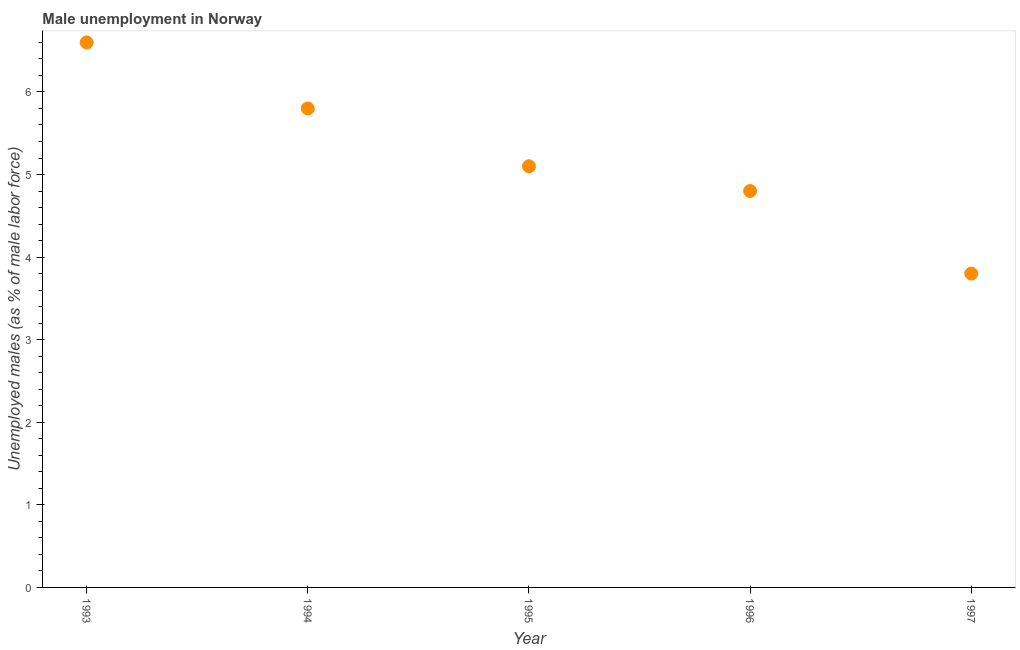What is the unemployed males population in 1993?
Ensure brevity in your answer.  6.6. Across all years, what is the maximum unemployed males population?
Make the answer very short. 6.6. Across all years, what is the minimum unemployed males population?
Give a very brief answer. 3.8. What is the sum of the unemployed males population?
Make the answer very short. 26.1. What is the difference between the unemployed males population in 1993 and 1994?
Offer a very short reply. 0.8. What is the average unemployed males population per year?
Offer a terse response. 5.22. What is the median unemployed males population?
Make the answer very short. 5.1. What is the ratio of the unemployed males population in 1993 to that in 1995?
Ensure brevity in your answer.  1.29. Is the difference between the unemployed males population in 1994 and 1995 greater than the difference between any two years?
Keep it short and to the point. No. What is the difference between the highest and the second highest unemployed males population?
Ensure brevity in your answer.  0.8. What is the difference between the highest and the lowest unemployed males population?
Make the answer very short. 2.8. In how many years, is the unemployed males population greater than the average unemployed males population taken over all years?
Your answer should be very brief. 2. Are the values on the major ticks of Y-axis written in scientific E-notation?
Your response must be concise. No. Does the graph contain any zero values?
Your answer should be compact. No. Does the graph contain grids?
Offer a terse response. No. What is the title of the graph?
Offer a very short reply. Male unemployment in Norway. What is the label or title of the Y-axis?
Offer a terse response. Unemployed males (as % of male labor force). What is the Unemployed males (as % of male labor force) in 1993?
Offer a terse response. 6.6. What is the Unemployed males (as % of male labor force) in 1994?
Your answer should be compact. 5.8. What is the Unemployed males (as % of male labor force) in 1995?
Your answer should be very brief. 5.1. What is the Unemployed males (as % of male labor force) in 1996?
Provide a short and direct response. 4.8. What is the Unemployed males (as % of male labor force) in 1997?
Make the answer very short. 3.8. What is the difference between the Unemployed males (as % of male labor force) in 1993 and 1994?
Give a very brief answer. 0.8. What is the difference between the Unemployed males (as % of male labor force) in 1993 and 1995?
Offer a very short reply. 1.5. What is the difference between the Unemployed males (as % of male labor force) in 1993 and 1996?
Give a very brief answer. 1.8. What is the difference between the Unemployed males (as % of male labor force) in 1993 and 1997?
Ensure brevity in your answer.  2.8. What is the difference between the Unemployed males (as % of male labor force) in 1994 and 1995?
Provide a short and direct response. 0.7. What is the difference between the Unemployed males (as % of male labor force) in 1994 and 1996?
Offer a very short reply. 1. What is the difference between the Unemployed males (as % of male labor force) in 1994 and 1997?
Provide a succinct answer. 2. What is the ratio of the Unemployed males (as % of male labor force) in 1993 to that in 1994?
Provide a succinct answer. 1.14. What is the ratio of the Unemployed males (as % of male labor force) in 1993 to that in 1995?
Offer a very short reply. 1.29. What is the ratio of the Unemployed males (as % of male labor force) in 1993 to that in 1996?
Your response must be concise. 1.38. What is the ratio of the Unemployed males (as % of male labor force) in 1993 to that in 1997?
Offer a terse response. 1.74. What is the ratio of the Unemployed males (as % of male labor force) in 1994 to that in 1995?
Provide a short and direct response. 1.14. What is the ratio of the Unemployed males (as % of male labor force) in 1994 to that in 1996?
Offer a terse response. 1.21. What is the ratio of the Unemployed males (as % of male labor force) in 1994 to that in 1997?
Your answer should be very brief. 1.53. What is the ratio of the Unemployed males (as % of male labor force) in 1995 to that in 1996?
Provide a succinct answer. 1.06. What is the ratio of the Unemployed males (as % of male labor force) in 1995 to that in 1997?
Your answer should be compact. 1.34. What is the ratio of the Unemployed males (as % of male labor force) in 1996 to that in 1997?
Your answer should be compact. 1.26. 